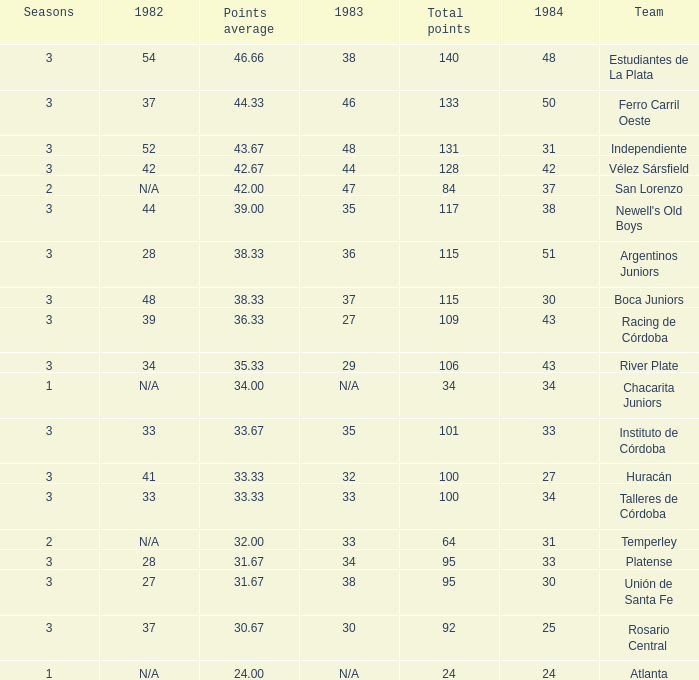What is the number of seasons for the team with a total fewer than 24? None. 